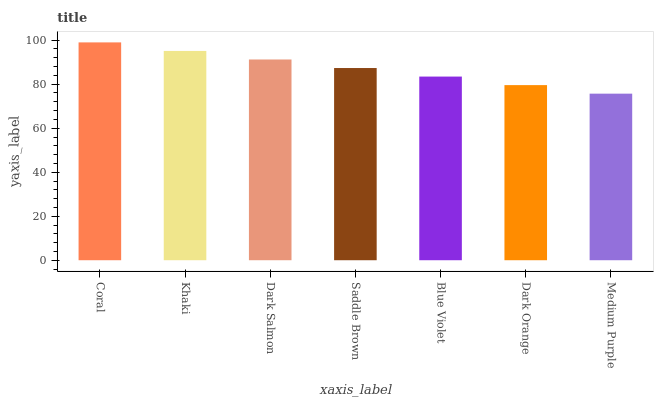Is Medium Purple the minimum?
Answer yes or no. Yes. Is Coral the maximum?
Answer yes or no. Yes. Is Khaki the minimum?
Answer yes or no. No. Is Khaki the maximum?
Answer yes or no. No. Is Coral greater than Khaki?
Answer yes or no. Yes. Is Khaki less than Coral?
Answer yes or no. Yes. Is Khaki greater than Coral?
Answer yes or no. No. Is Coral less than Khaki?
Answer yes or no. No. Is Saddle Brown the high median?
Answer yes or no. Yes. Is Saddle Brown the low median?
Answer yes or no. Yes. Is Coral the high median?
Answer yes or no. No. Is Dark Orange the low median?
Answer yes or no. No. 